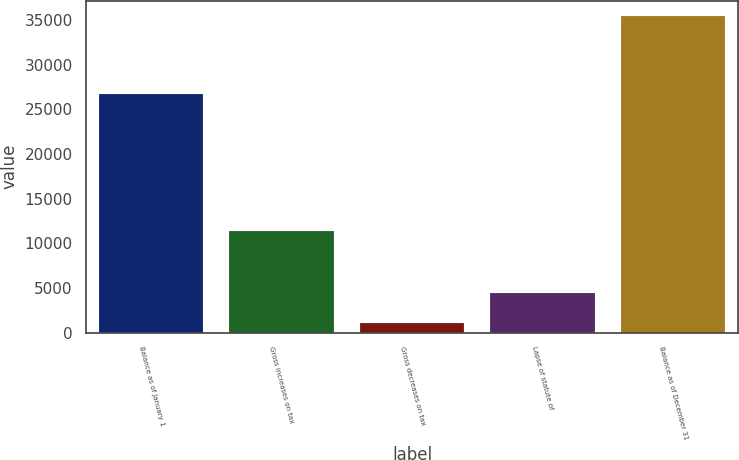Convert chart to OTSL. <chart><loc_0><loc_0><loc_500><loc_500><bar_chart><fcel>Balance as of January 1<fcel>Gross increases on tax<fcel>Gross decreases on tax<fcel>Lapse of statute of<fcel>Balance as of December 31<nl><fcel>26745<fcel>11365.8<fcel>1053<fcel>4490.6<fcel>35429<nl></chart> 